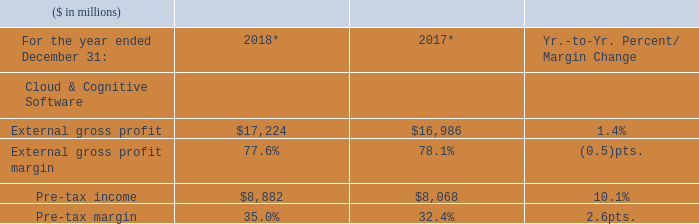Cloud & Cognitive Software revenue increased in 2018 compared to the prior year with growth in all three lines of business, as reported and adjusted for currency. Within Cognitive Applications, the increase was driven by strong double-digit growth in security services, while growth in Cloud & Data Platforms was led by analytics platforms and integration offerings. Transaction Processing Platforms grew with improved revenue performance sequentially in the fourth-quarter 2018 versus the third-quarter 2018 reflecting clients’ commitment to the company’s platform for the long term and the value it provides in managing mission-critical workloads. Within Cloud & Cognitive Software, cloud revenue of $3.0 billion grew 10 percent as reported and adjusted for currency compared to the prior year.
* Recast to reflect segment changes.
Gross margin in Cloud & Cognitive Software was impacted by an increased mix toward SaaS, a mix toward security services and increased royalty costs associated with IP licensing agreements compared to the prior year. Pre-tax income improvement year to year was primarily driven by operational efficiencies and mix.
What impacted the Gross margin in Cloud & Cognitive Software? Impacted by an increased mix toward saas, a mix toward security services and increased royalty costs associated with ip licensing agreements compared to the prior year. What drove the Pre-tax income improvement? Primarily driven by operational efficiencies and mix. What was the gross profit margin in 2018? 77.6%. What is the increase / (decrease) in the external gross profit from 2017 to 2018?
Answer scale should be: million. 17,224 - 16,986
Answer: 238. What is the average Pre-tax income?
Answer scale should be: million. (8,882 + 8,068) / 2
Answer: 8475. What is the increase / (decrease) in the Pre-tax margin from 2017 to 2018?
Answer scale should be: percent. 35.0% - 32.4%
Answer: 2.6. 